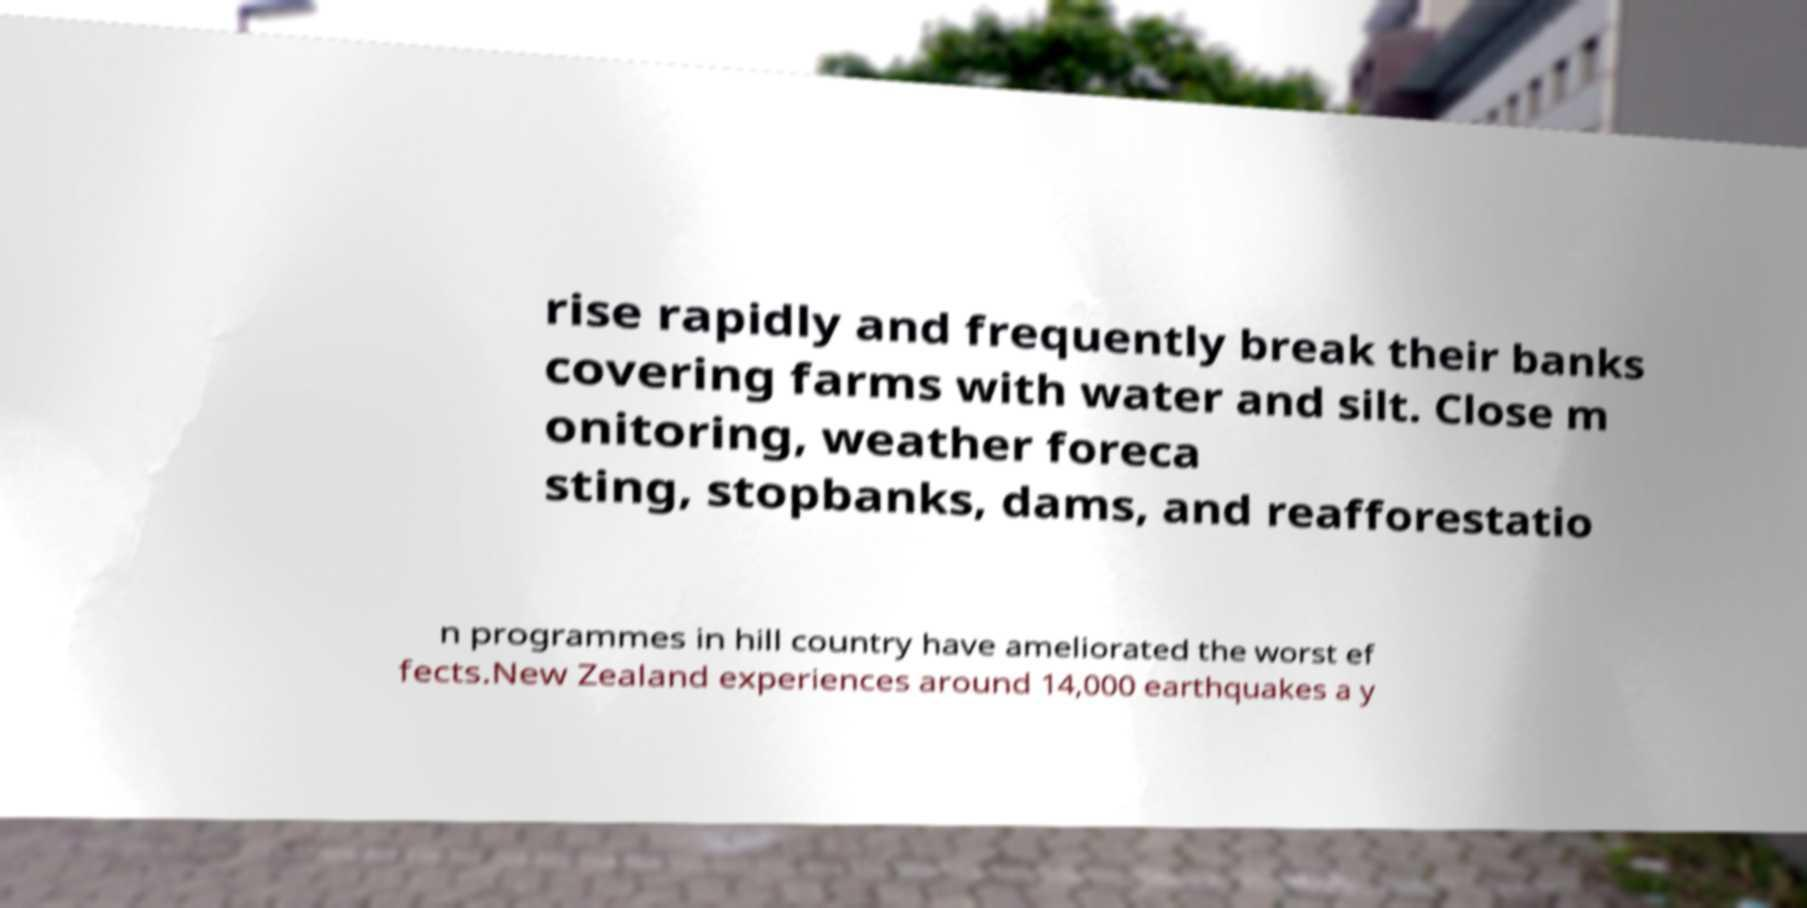Can you accurately transcribe the text from the provided image for me? rise rapidly and frequently break their banks covering farms with water and silt. Close m onitoring, weather foreca sting, stopbanks, dams, and reafforestatio n programmes in hill country have ameliorated the worst ef fects.New Zealand experiences around 14,000 earthquakes a y 